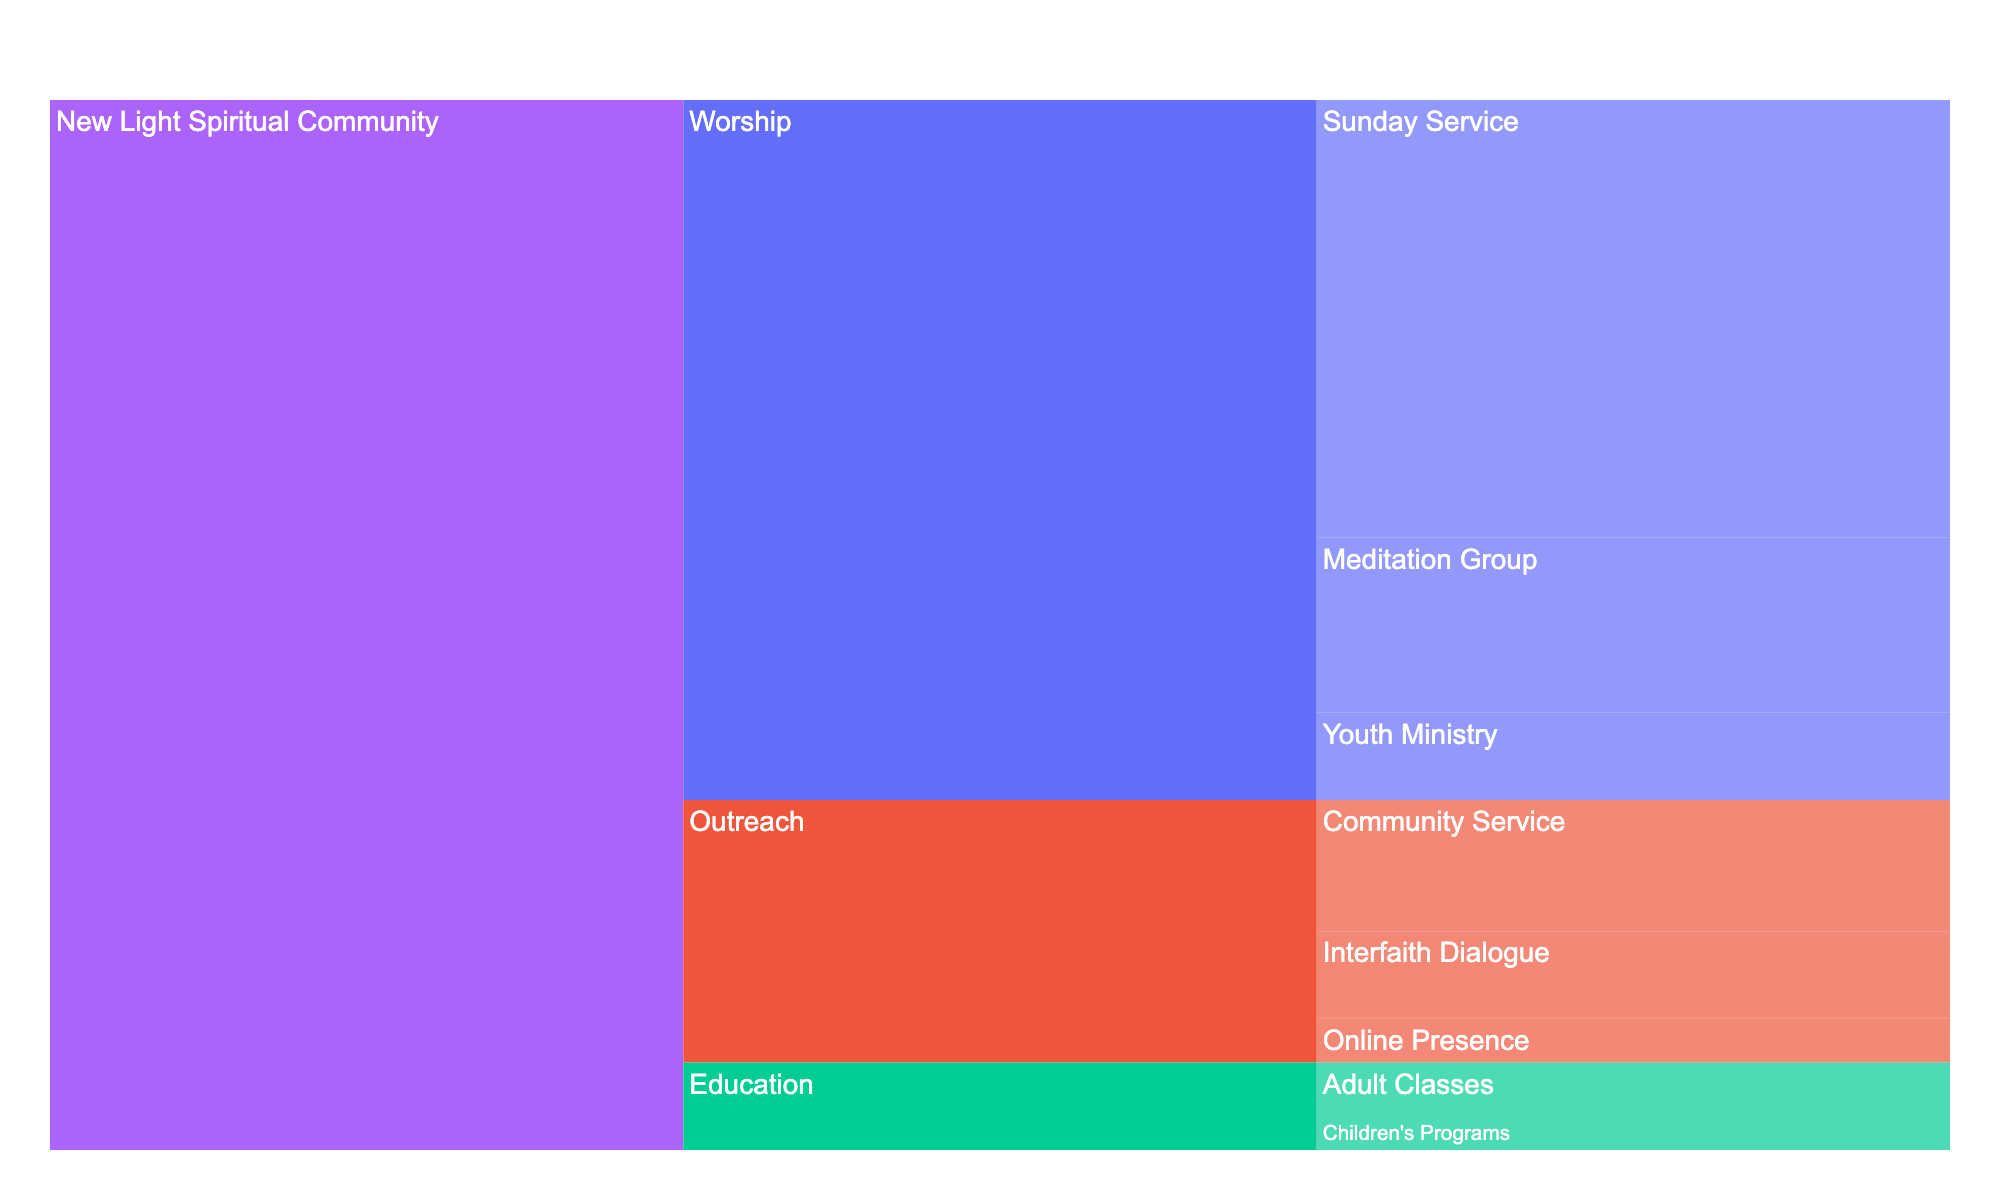How many members are there in the New Light Spiritual Community's Worship subgroup? Look at the icicle chart and identify the 'Worship' subgroup under the 'New Light Spiritual Community'. Its associated value represents the number of members.
Answer: 800 Which division within the Worship subgroup has the highest number of members? Navigate to the 'Worship' subgroup within the icicle chart and compare the member counts of its divisions: Sunday Service, Meditation Group, and Youth Ministry. The division with the highest number is the answer.
Answer: Sunday Service How many members are part of the Education subgroup? Find the 'Education' subgroup in the icicle chart and refer to its member count.
Answer: 100 What is the difference in membership numbers between the Worship subgroup's Sunday Service division and the Outreach subgroup's Community Service division? Identify the membership numbers for Sunday Service (500) and Community Service (150). Subtract the latter from the former to find the difference.
Answer: 350 Which subgroup has more members, Outreach or Education? Compare the member counts of the 'Outreach' subgroup (300) and the 'Education' subgroup (100) as indicated on the icicle chart.
Answer: Outreach What is the total number of members in the New Light Spiritual Community's Outreach subgroup? Sum the membership numbers of all divisions under the 'Outreach' subgroup: Community Service (150), Interfaith Dialogue (100), and Online Presence (50).
Answer: 300 What is the combined membership for the Meditation Group and Youth Ministry divisions within the Worship subgroup? Add the member counts for Meditation Group (200) and Youth Ministry (100).
Answer: 300 How many more members does the entire New Light Spiritual Community have compared to only its Worship subgroup? Subtract the total Worship subgroup membership (800) from the entire community membership (1200).
Answer: 400 Which division among all the subgroups in the New Light Spiritual Community has the least number of members? Compare the member counts of all divisions within the icicle chart: Sunday Service, Meditation Group, Youth Ministry, Community Service, Interfaith Dialogue, Online Presence, Adult Classes, and Children's Programs. Identify the division with the smallest value.
Answer: Online Presence In the Education subgroup, what percentage of the total members are in Adult Classes? Calculate the percentage by dividing the number of members in Adult Classes (60) by the total number of members in the Education subgroup (100) and then multiplying by 100.
Answer: 60% 